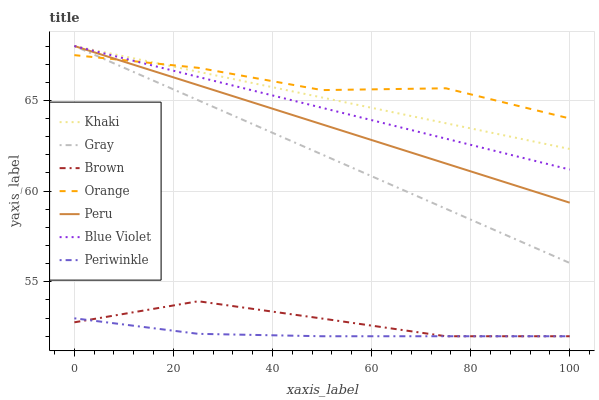Does Periwinkle have the minimum area under the curve?
Answer yes or no. Yes. Does Orange have the maximum area under the curve?
Answer yes or no. Yes. Does Khaki have the minimum area under the curve?
Answer yes or no. No. Does Khaki have the maximum area under the curve?
Answer yes or no. No. Is Gray the smoothest?
Answer yes or no. Yes. Is Orange the roughest?
Answer yes or no. Yes. Is Khaki the smoothest?
Answer yes or no. No. Is Khaki the roughest?
Answer yes or no. No. Does Brown have the lowest value?
Answer yes or no. Yes. Does Khaki have the lowest value?
Answer yes or no. No. Does Blue Violet have the highest value?
Answer yes or no. Yes. Does Brown have the highest value?
Answer yes or no. No. Is Brown less than Orange?
Answer yes or no. Yes. Is Khaki greater than Periwinkle?
Answer yes or no. Yes. Does Peru intersect Blue Violet?
Answer yes or no. Yes. Is Peru less than Blue Violet?
Answer yes or no. No. Is Peru greater than Blue Violet?
Answer yes or no. No. Does Brown intersect Orange?
Answer yes or no. No. 